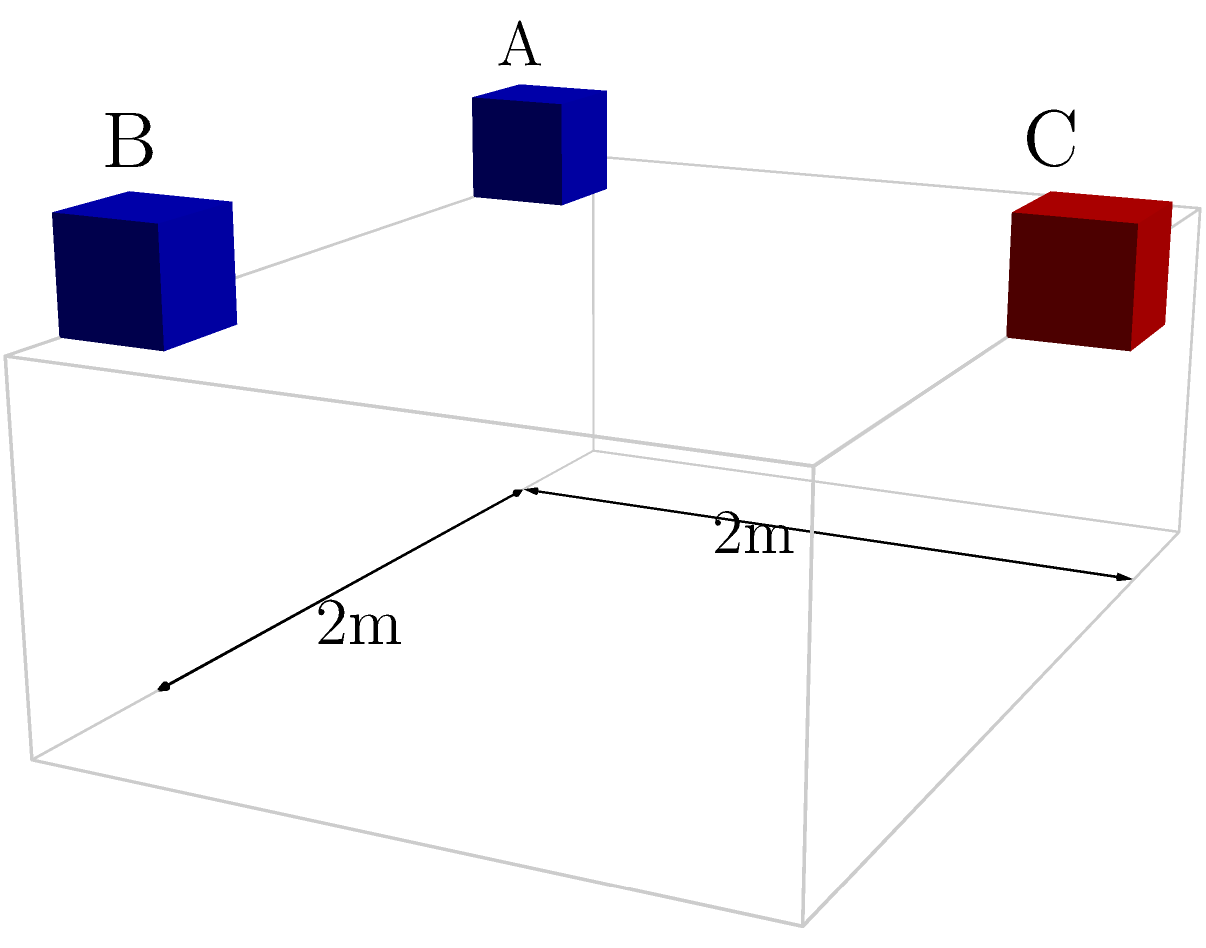In a DJ booth setup, three speakers are positioned as shown in the diagram. Speakers A and B are placed at the front corners of the booth, while speaker C is centered at the back. If the booth is 2m wide and 2m deep, what is the distance between speaker C and the midpoint of the line connecting speakers A and B? Let's approach this step-by-step:

1) First, we need to establish a coordinate system. Let's place the origin at the front left corner of the booth, with the x-axis along the width, y-axis along the depth, and z-axis for height.

2) The coordinates of the speakers are:
   A: (0.5, 0, 1)
   B: (2.5, 0, 1)
   C: (1.5, 2, 1)

3) The midpoint M of the line connecting A and B is:
   M: ((0.5 + 2.5)/2, 0, 1) = (1.5, 0, 1)

4) Now we need to find the distance between C and M. We can use the distance formula in 3D space:

   $$d = \sqrt{(x_2-x_1)^2 + (y_2-y_1)^2 + (z_2-z_1)^2}$$

5) Plugging in the coordinates:

   $$d = \sqrt{(1.5-1.5)^2 + (2-0)^2 + (1-1)^2}$$

6) Simplifying:

   $$d = \sqrt{0^2 + 2^2 + 0^2} = \sqrt{4} = 2$$

Therefore, the distance between speaker C and the midpoint of the line connecting speakers A and B is 2 meters.
Answer: 2 meters 